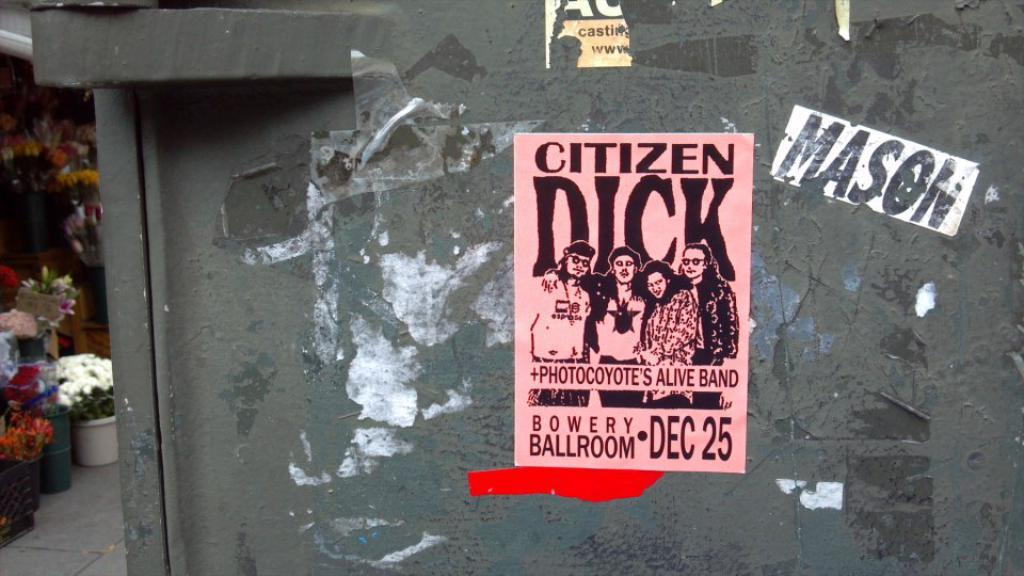<image>
Give a short and clear explanation of the subsequent image. A posted flyer announces that the band Citizen Dick will be playing at the Bowery Ballroom on Christmas Day. 